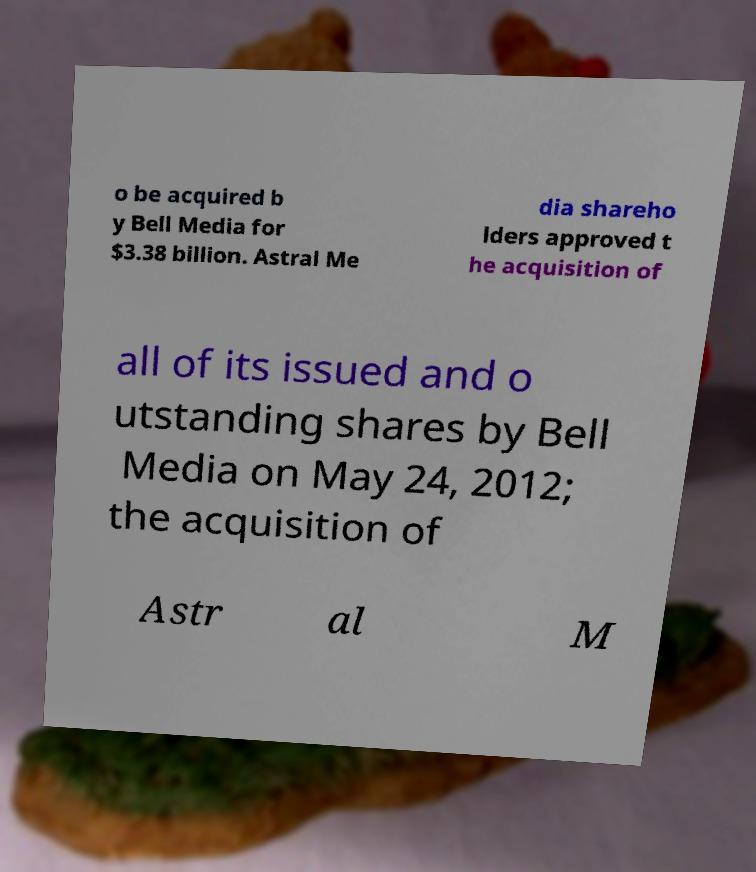Could you assist in decoding the text presented in this image and type it out clearly? o be acquired b y Bell Media for $3.38 billion. Astral Me dia shareho lders approved t he acquisition of all of its issued and o utstanding shares by Bell Media on May 24, 2012; the acquisition of Astr al M 